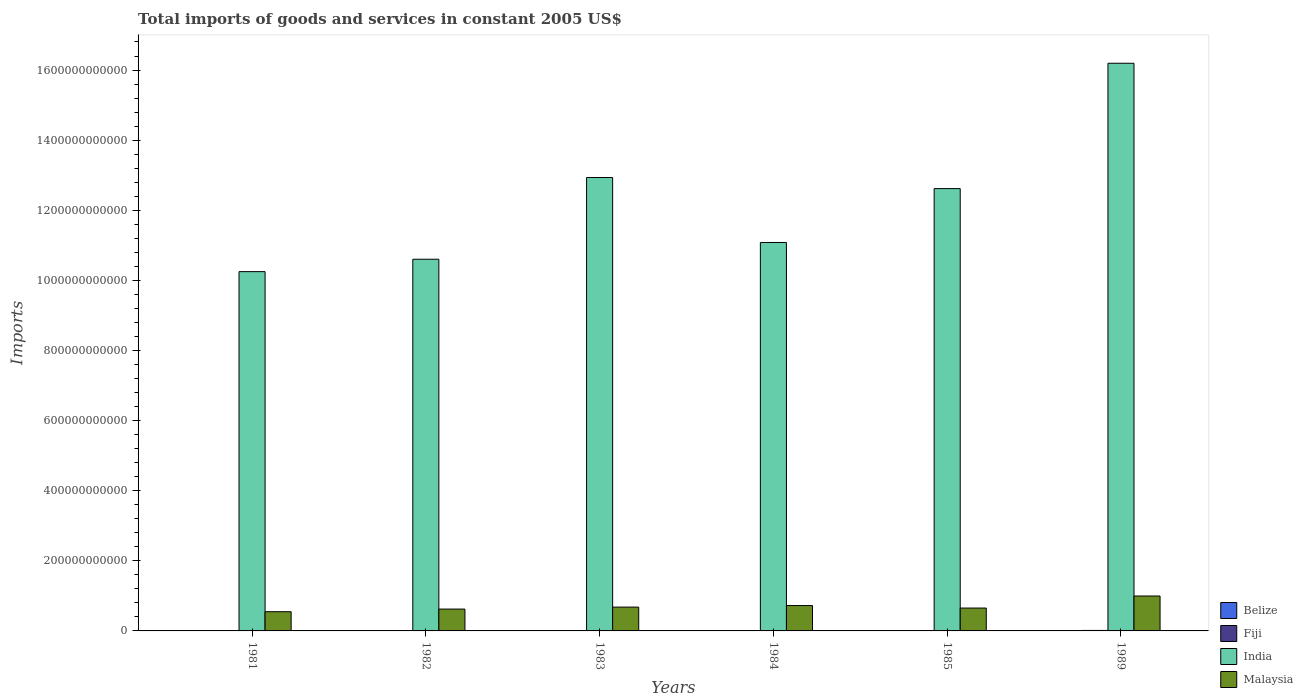How many different coloured bars are there?
Your answer should be very brief. 4. Are the number of bars per tick equal to the number of legend labels?
Make the answer very short. Yes. How many bars are there on the 4th tick from the left?
Offer a terse response. 4. What is the total imports of goods and services in Fiji in 1983?
Offer a terse response. 9.05e+08. Across all years, what is the maximum total imports of goods and services in Malaysia?
Offer a terse response. 9.96e+1. Across all years, what is the minimum total imports of goods and services in Fiji?
Offer a terse response. 8.65e+08. What is the total total imports of goods and services in Belize in the graph?
Your answer should be compact. 2.58e+09. What is the difference between the total imports of goods and services in Malaysia in 1983 and that in 1984?
Give a very brief answer. -4.42e+09. What is the difference between the total imports of goods and services in Belize in 1983 and the total imports of goods and services in Fiji in 1984?
Your answer should be very brief. -5.09e+08. What is the average total imports of goods and services in Fiji per year?
Provide a short and direct response. 1.01e+09. In the year 1981, what is the difference between the total imports of goods and services in Malaysia and total imports of goods and services in India?
Ensure brevity in your answer.  -9.70e+11. In how many years, is the total imports of goods and services in India greater than 1080000000000 US$?
Your answer should be very brief. 4. What is the ratio of the total imports of goods and services in Belize in 1982 to that in 1984?
Give a very brief answer. 1.01. Is the difference between the total imports of goods and services in Malaysia in 1981 and 1989 greater than the difference between the total imports of goods and services in India in 1981 and 1989?
Ensure brevity in your answer.  Yes. What is the difference between the highest and the second highest total imports of goods and services in Fiji?
Provide a short and direct response. 3.37e+08. What is the difference between the highest and the lowest total imports of goods and services in Malaysia?
Your answer should be very brief. 4.48e+1. In how many years, is the total imports of goods and services in India greater than the average total imports of goods and services in India taken over all years?
Give a very brief answer. 3. What does the 1st bar from the right in 1985 represents?
Make the answer very short. Malaysia. Is it the case that in every year, the sum of the total imports of goods and services in India and total imports of goods and services in Belize is greater than the total imports of goods and services in Malaysia?
Provide a succinct answer. Yes. What is the difference between two consecutive major ticks on the Y-axis?
Your answer should be very brief. 2.00e+11. What is the title of the graph?
Your answer should be very brief. Total imports of goods and services in constant 2005 US$. What is the label or title of the X-axis?
Provide a succinct answer. Years. What is the label or title of the Y-axis?
Keep it short and to the point. Imports. What is the Imports in Belize in 1981?
Provide a short and direct response. 4.41e+08. What is the Imports in Fiji in 1981?
Offer a terse response. 1.06e+09. What is the Imports of India in 1981?
Provide a short and direct response. 1.02e+12. What is the Imports of Malaysia in 1981?
Offer a very short reply. 5.48e+1. What is the Imports of Belize in 1982?
Your answer should be compact. 4.12e+08. What is the Imports in Fiji in 1982?
Provide a succinct answer. 9.40e+08. What is the Imports of India in 1982?
Your answer should be compact. 1.06e+12. What is the Imports in Malaysia in 1982?
Provide a short and direct response. 6.23e+1. What is the Imports in Belize in 1983?
Your answer should be very brief. 3.72e+08. What is the Imports in Fiji in 1983?
Make the answer very short. 9.05e+08. What is the Imports of India in 1983?
Your response must be concise. 1.29e+12. What is the Imports in Malaysia in 1983?
Offer a terse response. 6.79e+1. What is the Imports of Belize in 1984?
Ensure brevity in your answer.  4.09e+08. What is the Imports of Fiji in 1984?
Make the answer very short. 8.81e+08. What is the Imports of India in 1984?
Provide a short and direct response. 1.11e+12. What is the Imports in Malaysia in 1984?
Offer a terse response. 7.24e+1. What is the Imports of Belize in 1985?
Offer a terse response. 3.61e+08. What is the Imports in Fiji in 1985?
Provide a succinct answer. 8.65e+08. What is the Imports of India in 1985?
Your response must be concise. 1.26e+12. What is the Imports of Malaysia in 1985?
Offer a very short reply. 6.52e+1. What is the Imports in Belize in 1989?
Offer a very short reply. 5.85e+08. What is the Imports in Fiji in 1989?
Your response must be concise. 1.39e+09. What is the Imports in India in 1989?
Offer a terse response. 1.62e+12. What is the Imports in Malaysia in 1989?
Ensure brevity in your answer.  9.96e+1. Across all years, what is the maximum Imports of Belize?
Your response must be concise. 5.85e+08. Across all years, what is the maximum Imports of Fiji?
Your answer should be very brief. 1.39e+09. Across all years, what is the maximum Imports of India?
Keep it short and to the point. 1.62e+12. Across all years, what is the maximum Imports of Malaysia?
Your answer should be compact. 9.96e+1. Across all years, what is the minimum Imports of Belize?
Your answer should be very brief. 3.61e+08. Across all years, what is the minimum Imports of Fiji?
Offer a terse response. 8.65e+08. Across all years, what is the minimum Imports of India?
Provide a short and direct response. 1.02e+12. Across all years, what is the minimum Imports in Malaysia?
Your response must be concise. 5.48e+1. What is the total Imports of Belize in the graph?
Keep it short and to the point. 2.58e+09. What is the total Imports in Fiji in the graph?
Your answer should be very brief. 6.04e+09. What is the total Imports of India in the graph?
Offer a terse response. 7.37e+12. What is the total Imports of Malaysia in the graph?
Ensure brevity in your answer.  4.22e+11. What is the difference between the Imports in Belize in 1981 and that in 1982?
Your answer should be very brief. 2.92e+07. What is the difference between the Imports of Fiji in 1981 and that in 1982?
Your answer should be compact. 1.15e+08. What is the difference between the Imports in India in 1981 and that in 1982?
Your response must be concise. -3.54e+1. What is the difference between the Imports of Malaysia in 1981 and that in 1982?
Your answer should be very brief. -7.54e+09. What is the difference between the Imports of Belize in 1981 and that in 1983?
Give a very brief answer. 6.97e+07. What is the difference between the Imports of Fiji in 1981 and that in 1983?
Your answer should be very brief. 1.50e+08. What is the difference between the Imports of India in 1981 and that in 1983?
Keep it short and to the point. -2.69e+11. What is the difference between the Imports in Malaysia in 1981 and that in 1983?
Keep it short and to the point. -1.31e+1. What is the difference between the Imports in Belize in 1981 and that in 1984?
Provide a succinct answer. 3.24e+07. What is the difference between the Imports in Fiji in 1981 and that in 1984?
Keep it short and to the point. 1.75e+08. What is the difference between the Imports in India in 1981 and that in 1984?
Your response must be concise. -8.32e+1. What is the difference between the Imports of Malaysia in 1981 and that in 1984?
Keep it short and to the point. -1.76e+1. What is the difference between the Imports of Belize in 1981 and that in 1985?
Your answer should be compact. 8.02e+07. What is the difference between the Imports in Fiji in 1981 and that in 1985?
Offer a terse response. 1.90e+08. What is the difference between the Imports in India in 1981 and that in 1985?
Offer a very short reply. -2.37e+11. What is the difference between the Imports in Malaysia in 1981 and that in 1985?
Your response must be concise. -1.05e+1. What is the difference between the Imports of Belize in 1981 and that in 1989?
Keep it short and to the point. -1.44e+08. What is the difference between the Imports of Fiji in 1981 and that in 1989?
Offer a terse response. -3.37e+08. What is the difference between the Imports in India in 1981 and that in 1989?
Provide a short and direct response. -5.94e+11. What is the difference between the Imports in Malaysia in 1981 and that in 1989?
Give a very brief answer. -4.48e+1. What is the difference between the Imports of Belize in 1982 and that in 1983?
Your answer should be compact. 4.05e+07. What is the difference between the Imports in Fiji in 1982 and that in 1983?
Offer a terse response. 3.47e+07. What is the difference between the Imports in India in 1982 and that in 1983?
Provide a succinct answer. -2.33e+11. What is the difference between the Imports in Malaysia in 1982 and that in 1983?
Your answer should be compact. -5.61e+09. What is the difference between the Imports in Belize in 1982 and that in 1984?
Offer a terse response. 3.23e+06. What is the difference between the Imports in Fiji in 1982 and that in 1984?
Provide a succinct answer. 5.93e+07. What is the difference between the Imports in India in 1982 and that in 1984?
Offer a terse response. -4.78e+1. What is the difference between the Imports of Malaysia in 1982 and that in 1984?
Provide a short and direct response. -1.00e+1. What is the difference between the Imports of Belize in 1982 and that in 1985?
Offer a terse response. 5.10e+07. What is the difference between the Imports of Fiji in 1982 and that in 1985?
Your response must be concise. 7.51e+07. What is the difference between the Imports in India in 1982 and that in 1985?
Your answer should be very brief. -2.01e+11. What is the difference between the Imports of Malaysia in 1982 and that in 1985?
Your answer should be compact. -2.91e+09. What is the difference between the Imports in Belize in 1982 and that in 1989?
Your answer should be compact. -1.73e+08. What is the difference between the Imports in Fiji in 1982 and that in 1989?
Offer a terse response. -4.52e+08. What is the difference between the Imports of India in 1982 and that in 1989?
Keep it short and to the point. -5.59e+11. What is the difference between the Imports of Malaysia in 1982 and that in 1989?
Offer a very short reply. -3.73e+1. What is the difference between the Imports in Belize in 1983 and that in 1984?
Provide a short and direct response. -3.73e+07. What is the difference between the Imports of Fiji in 1983 and that in 1984?
Give a very brief answer. 2.47e+07. What is the difference between the Imports in India in 1983 and that in 1984?
Your response must be concise. 1.85e+11. What is the difference between the Imports in Malaysia in 1983 and that in 1984?
Your answer should be very brief. -4.42e+09. What is the difference between the Imports in Belize in 1983 and that in 1985?
Give a very brief answer. 1.05e+07. What is the difference between the Imports in Fiji in 1983 and that in 1985?
Offer a very short reply. 4.04e+07. What is the difference between the Imports in India in 1983 and that in 1985?
Give a very brief answer. 3.16e+1. What is the difference between the Imports in Malaysia in 1983 and that in 1985?
Make the answer very short. 2.70e+09. What is the difference between the Imports of Belize in 1983 and that in 1989?
Your answer should be very brief. -2.14e+08. What is the difference between the Imports in Fiji in 1983 and that in 1989?
Ensure brevity in your answer.  -4.87e+08. What is the difference between the Imports in India in 1983 and that in 1989?
Ensure brevity in your answer.  -3.26e+11. What is the difference between the Imports of Malaysia in 1983 and that in 1989?
Offer a very short reply. -3.17e+1. What is the difference between the Imports of Belize in 1984 and that in 1985?
Your response must be concise. 4.78e+07. What is the difference between the Imports of Fiji in 1984 and that in 1985?
Your answer should be very brief. 1.58e+07. What is the difference between the Imports in India in 1984 and that in 1985?
Give a very brief answer. -1.54e+11. What is the difference between the Imports in Malaysia in 1984 and that in 1985?
Ensure brevity in your answer.  7.12e+09. What is the difference between the Imports in Belize in 1984 and that in 1989?
Your answer should be compact. -1.76e+08. What is the difference between the Imports in Fiji in 1984 and that in 1989?
Your answer should be compact. -5.11e+08. What is the difference between the Imports in India in 1984 and that in 1989?
Make the answer very short. -5.11e+11. What is the difference between the Imports of Malaysia in 1984 and that in 1989?
Keep it short and to the point. -2.73e+1. What is the difference between the Imports of Belize in 1985 and that in 1989?
Ensure brevity in your answer.  -2.24e+08. What is the difference between the Imports of Fiji in 1985 and that in 1989?
Your answer should be compact. -5.27e+08. What is the difference between the Imports in India in 1985 and that in 1989?
Ensure brevity in your answer.  -3.58e+11. What is the difference between the Imports in Malaysia in 1985 and that in 1989?
Give a very brief answer. -3.44e+1. What is the difference between the Imports of Belize in 1981 and the Imports of Fiji in 1982?
Make the answer very short. -4.98e+08. What is the difference between the Imports of Belize in 1981 and the Imports of India in 1982?
Provide a succinct answer. -1.06e+12. What is the difference between the Imports of Belize in 1981 and the Imports of Malaysia in 1982?
Keep it short and to the point. -6.19e+1. What is the difference between the Imports in Fiji in 1981 and the Imports in India in 1982?
Ensure brevity in your answer.  -1.06e+12. What is the difference between the Imports of Fiji in 1981 and the Imports of Malaysia in 1982?
Offer a terse response. -6.13e+1. What is the difference between the Imports in India in 1981 and the Imports in Malaysia in 1982?
Your answer should be very brief. 9.63e+11. What is the difference between the Imports in Belize in 1981 and the Imports in Fiji in 1983?
Provide a short and direct response. -4.64e+08. What is the difference between the Imports of Belize in 1981 and the Imports of India in 1983?
Your answer should be very brief. -1.29e+12. What is the difference between the Imports in Belize in 1981 and the Imports in Malaysia in 1983?
Ensure brevity in your answer.  -6.75e+1. What is the difference between the Imports of Fiji in 1981 and the Imports of India in 1983?
Your response must be concise. -1.29e+12. What is the difference between the Imports in Fiji in 1981 and the Imports in Malaysia in 1983?
Your answer should be very brief. -6.69e+1. What is the difference between the Imports in India in 1981 and the Imports in Malaysia in 1983?
Offer a very short reply. 9.57e+11. What is the difference between the Imports of Belize in 1981 and the Imports of Fiji in 1984?
Provide a short and direct response. -4.39e+08. What is the difference between the Imports of Belize in 1981 and the Imports of India in 1984?
Give a very brief answer. -1.11e+12. What is the difference between the Imports of Belize in 1981 and the Imports of Malaysia in 1984?
Make the answer very short. -7.19e+1. What is the difference between the Imports of Fiji in 1981 and the Imports of India in 1984?
Make the answer very short. -1.11e+12. What is the difference between the Imports of Fiji in 1981 and the Imports of Malaysia in 1984?
Provide a succinct answer. -7.13e+1. What is the difference between the Imports in India in 1981 and the Imports in Malaysia in 1984?
Your answer should be very brief. 9.53e+11. What is the difference between the Imports of Belize in 1981 and the Imports of Fiji in 1985?
Your answer should be compact. -4.23e+08. What is the difference between the Imports in Belize in 1981 and the Imports in India in 1985?
Your response must be concise. -1.26e+12. What is the difference between the Imports of Belize in 1981 and the Imports of Malaysia in 1985?
Provide a short and direct response. -6.48e+1. What is the difference between the Imports in Fiji in 1981 and the Imports in India in 1985?
Keep it short and to the point. -1.26e+12. What is the difference between the Imports of Fiji in 1981 and the Imports of Malaysia in 1985?
Offer a terse response. -6.42e+1. What is the difference between the Imports of India in 1981 and the Imports of Malaysia in 1985?
Provide a succinct answer. 9.60e+11. What is the difference between the Imports of Belize in 1981 and the Imports of Fiji in 1989?
Provide a succinct answer. -9.50e+08. What is the difference between the Imports in Belize in 1981 and the Imports in India in 1989?
Make the answer very short. -1.62e+12. What is the difference between the Imports in Belize in 1981 and the Imports in Malaysia in 1989?
Your answer should be compact. -9.92e+1. What is the difference between the Imports of Fiji in 1981 and the Imports of India in 1989?
Your answer should be compact. -1.62e+12. What is the difference between the Imports of Fiji in 1981 and the Imports of Malaysia in 1989?
Provide a short and direct response. -9.86e+1. What is the difference between the Imports in India in 1981 and the Imports in Malaysia in 1989?
Keep it short and to the point. 9.25e+11. What is the difference between the Imports of Belize in 1982 and the Imports of Fiji in 1983?
Your answer should be compact. -4.93e+08. What is the difference between the Imports in Belize in 1982 and the Imports in India in 1983?
Ensure brevity in your answer.  -1.29e+12. What is the difference between the Imports in Belize in 1982 and the Imports in Malaysia in 1983?
Give a very brief answer. -6.75e+1. What is the difference between the Imports of Fiji in 1982 and the Imports of India in 1983?
Provide a succinct answer. -1.29e+12. What is the difference between the Imports of Fiji in 1982 and the Imports of Malaysia in 1983?
Offer a very short reply. -6.70e+1. What is the difference between the Imports of India in 1982 and the Imports of Malaysia in 1983?
Provide a succinct answer. 9.92e+11. What is the difference between the Imports in Belize in 1982 and the Imports in Fiji in 1984?
Offer a very short reply. -4.68e+08. What is the difference between the Imports in Belize in 1982 and the Imports in India in 1984?
Offer a very short reply. -1.11e+12. What is the difference between the Imports in Belize in 1982 and the Imports in Malaysia in 1984?
Give a very brief answer. -7.20e+1. What is the difference between the Imports in Fiji in 1982 and the Imports in India in 1984?
Your response must be concise. -1.11e+12. What is the difference between the Imports in Fiji in 1982 and the Imports in Malaysia in 1984?
Give a very brief answer. -7.14e+1. What is the difference between the Imports in India in 1982 and the Imports in Malaysia in 1984?
Provide a short and direct response. 9.88e+11. What is the difference between the Imports of Belize in 1982 and the Imports of Fiji in 1985?
Your answer should be very brief. -4.53e+08. What is the difference between the Imports of Belize in 1982 and the Imports of India in 1985?
Keep it short and to the point. -1.26e+12. What is the difference between the Imports in Belize in 1982 and the Imports in Malaysia in 1985?
Offer a very short reply. -6.48e+1. What is the difference between the Imports in Fiji in 1982 and the Imports in India in 1985?
Your answer should be very brief. -1.26e+12. What is the difference between the Imports of Fiji in 1982 and the Imports of Malaysia in 1985?
Your answer should be compact. -6.43e+1. What is the difference between the Imports of India in 1982 and the Imports of Malaysia in 1985?
Offer a terse response. 9.95e+11. What is the difference between the Imports in Belize in 1982 and the Imports in Fiji in 1989?
Offer a very short reply. -9.79e+08. What is the difference between the Imports of Belize in 1982 and the Imports of India in 1989?
Your answer should be very brief. -1.62e+12. What is the difference between the Imports in Belize in 1982 and the Imports in Malaysia in 1989?
Give a very brief answer. -9.92e+1. What is the difference between the Imports in Fiji in 1982 and the Imports in India in 1989?
Offer a terse response. -1.62e+12. What is the difference between the Imports of Fiji in 1982 and the Imports of Malaysia in 1989?
Give a very brief answer. -9.87e+1. What is the difference between the Imports in India in 1982 and the Imports in Malaysia in 1989?
Give a very brief answer. 9.61e+11. What is the difference between the Imports of Belize in 1983 and the Imports of Fiji in 1984?
Provide a succinct answer. -5.09e+08. What is the difference between the Imports of Belize in 1983 and the Imports of India in 1984?
Make the answer very short. -1.11e+12. What is the difference between the Imports of Belize in 1983 and the Imports of Malaysia in 1984?
Your response must be concise. -7.20e+1. What is the difference between the Imports in Fiji in 1983 and the Imports in India in 1984?
Your response must be concise. -1.11e+12. What is the difference between the Imports in Fiji in 1983 and the Imports in Malaysia in 1984?
Give a very brief answer. -7.15e+1. What is the difference between the Imports in India in 1983 and the Imports in Malaysia in 1984?
Ensure brevity in your answer.  1.22e+12. What is the difference between the Imports in Belize in 1983 and the Imports in Fiji in 1985?
Offer a very short reply. -4.93e+08. What is the difference between the Imports of Belize in 1983 and the Imports of India in 1985?
Keep it short and to the point. -1.26e+12. What is the difference between the Imports in Belize in 1983 and the Imports in Malaysia in 1985?
Give a very brief answer. -6.49e+1. What is the difference between the Imports of Fiji in 1983 and the Imports of India in 1985?
Your response must be concise. -1.26e+12. What is the difference between the Imports in Fiji in 1983 and the Imports in Malaysia in 1985?
Provide a succinct answer. -6.43e+1. What is the difference between the Imports of India in 1983 and the Imports of Malaysia in 1985?
Your answer should be very brief. 1.23e+12. What is the difference between the Imports in Belize in 1983 and the Imports in Fiji in 1989?
Ensure brevity in your answer.  -1.02e+09. What is the difference between the Imports of Belize in 1983 and the Imports of India in 1989?
Your answer should be very brief. -1.62e+12. What is the difference between the Imports in Belize in 1983 and the Imports in Malaysia in 1989?
Give a very brief answer. -9.92e+1. What is the difference between the Imports of Fiji in 1983 and the Imports of India in 1989?
Ensure brevity in your answer.  -1.62e+12. What is the difference between the Imports in Fiji in 1983 and the Imports in Malaysia in 1989?
Offer a terse response. -9.87e+1. What is the difference between the Imports of India in 1983 and the Imports of Malaysia in 1989?
Provide a succinct answer. 1.19e+12. What is the difference between the Imports in Belize in 1984 and the Imports in Fiji in 1985?
Provide a short and direct response. -4.56e+08. What is the difference between the Imports in Belize in 1984 and the Imports in India in 1985?
Your response must be concise. -1.26e+12. What is the difference between the Imports in Belize in 1984 and the Imports in Malaysia in 1985?
Make the answer very short. -6.48e+1. What is the difference between the Imports of Fiji in 1984 and the Imports of India in 1985?
Keep it short and to the point. -1.26e+12. What is the difference between the Imports of Fiji in 1984 and the Imports of Malaysia in 1985?
Give a very brief answer. -6.44e+1. What is the difference between the Imports in India in 1984 and the Imports in Malaysia in 1985?
Provide a succinct answer. 1.04e+12. What is the difference between the Imports in Belize in 1984 and the Imports in Fiji in 1989?
Your answer should be very brief. -9.83e+08. What is the difference between the Imports of Belize in 1984 and the Imports of India in 1989?
Your answer should be very brief. -1.62e+12. What is the difference between the Imports in Belize in 1984 and the Imports in Malaysia in 1989?
Ensure brevity in your answer.  -9.92e+1. What is the difference between the Imports of Fiji in 1984 and the Imports of India in 1989?
Your answer should be compact. -1.62e+12. What is the difference between the Imports in Fiji in 1984 and the Imports in Malaysia in 1989?
Provide a short and direct response. -9.87e+1. What is the difference between the Imports of India in 1984 and the Imports of Malaysia in 1989?
Your answer should be compact. 1.01e+12. What is the difference between the Imports in Belize in 1985 and the Imports in Fiji in 1989?
Offer a very short reply. -1.03e+09. What is the difference between the Imports of Belize in 1985 and the Imports of India in 1989?
Your response must be concise. -1.62e+12. What is the difference between the Imports in Belize in 1985 and the Imports in Malaysia in 1989?
Your answer should be very brief. -9.93e+1. What is the difference between the Imports of Fiji in 1985 and the Imports of India in 1989?
Provide a short and direct response. -1.62e+12. What is the difference between the Imports of Fiji in 1985 and the Imports of Malaysia in 1989?
Provide a short and direct response. -9.87e+1. What is the difference between the Imports of India in 1985 and the Imports of Malaysia in 1989?
Offer a very short reply. 1.16e+12. What is the average Imports in Belize per year?
Your answer should be compact. 4.30e+08. What is the average Imports in Fiji per year?
Offer a very short reply. 1.01e+09. What is the average Imports of India per year?
Offer a very short reply. 1.23e+12. What is the average Imports in Malaysia per year?
Your response must be concise. 7.04e+1. In the year 1981, what is the difference between the Imports in Belize and Imports in Fiji?
Offer a terse response. -6.14e+08. In the year 1981, what is the difference between the Imports in Belize and Imports in India?
Make the answer very short. -1.02e+12. In the year 1981, what is the difference between the Imports of Belize and Imports of Malaysia?
Offer a very short reply. -5.44e+1. In the year 1981, what is the difference between the Imports of Fiji and Imports of India?
Offer a very short reply. -1.02e+12. In the year 1981, what is the difference between the Imports of Fiji and Imports of Malaysia?
Give a very brief answer. -5.37e+1. In the year 1981, what is the difference between the Imports in India and Imports in Malaysia?
Offer a terse response. 9.70e+11. In the year 1982, what is the difference between the Imports of Belize and Imports of Fiji?
Your answer should be very brief. -5.28e+08. In the year 1982, what is the difference between the Imports in Belize and Imports in India?
Make the answer very short. -1.06e+12. In the year 1982, what is the difference between the Imports in Belize and Imports in Malaysia?
Give a very brief answer. -6.19e+1. In the year 1982, what is the difference between the Imports in Fiji and Imports in India?
Keep it short and to the point. -1.06e+12. In the year 1982, what is the difference between the Imports of Fiji and Imports of Malaysia?
Provide a short and direct response. -6.14e+1. In the year 1982, what is the difference between the Imports in India and Imports in Malaysia?
Offer a very short reply. 9.98e+11. In the year 1983, what is the difference between the Imports of Belize and Imports of Fiji?
Make the answer very short. -5.34e+08. In the year 1983, what is the difference between the Imports of Belize and Imports of India?
Give a very brief answer. -1.29e+12. In the year 1983, what is the difference between the Imports in Belize and Imports in Malaysia?
Your response must be concise. -6.76e+1. In the year 1983, what is the difference between the Imports of Fiji and Imports of India?
Offer a terse response. -1.29e+12. In the year 1983, what is the difference between the Imports of Fiji and Imports of Malaysia?
Ensure brevity in your answer.  -6.70e+1. In the year 1983, what is the difference between the Imports of India and Imports of Malaysia?
Make the answer very short. 1.23e+12. In the year 1984, what is the difference between the Imports of Belize and Imports of Fiji?
Ensure brevity in your answer.  -4.72e+08. In the year 1984, what is the difference between the Imports of Belize and Imports of India?
Keep it short and to the point. -1.11e+12. In the year 1984, what is the difference between the Imports of Belize and Imports of Malaysia?
Offer a very short reply. -7.20e+1. In the year 1984, what is the difference between the Imports in Fiji and Imports in India?
Provide a short and direct response. -1.11e+12. In the year 1984, what is the difference between the Imports in Fiji and Imports in Malaysia?
Offer a terse response. -7.15e+1. In the year 1984, what is the difference between the Imports in India and Imports in Malaysia?
Provide a short and direct response. 1.04e+12. In the year 1985, what is the difference between the Imports of Belize and Imports of Fiji?
Keep it short and to the point. -5.04e+08. In the year 1985, what is the difference between the Imports of Belize and Imports of India?
Provide a succinct answer. -1.26e+12. In the year 1985, what is the difference between the Imports in Belize and Imports in Malaysia?
Your answer should be very brief. -6.49e+1. In the year 1985, what is the difference between the Imports of Fiji and Imports of India?
Keep it short and to the point. -1.26e+12. In the year 1985, what is the difference between the Imports of Fiji and Imports of Malaysia?
Your response must be concise. -6.44e+1. In the year 1985, what is the difference between the Imports of India and Imports of Malaysia?
Offer a very short reply. 1.20e+12. In the year 1989, what is the difference between the Imports of Belize and Imports of Fiji?
Provide a succinct answer. -8.06e+08. In the year 1989, what is the difference between the Imports of Belize and Imports of India?
Your response must be concise. -1.62e+12. In the year 1989, what is the difference between the Imports of Belize and Imports of Malaysia?
Your answer should be compact. -9.90e+1. In the year 1989, what is the difference between the Imports in Fiji and Imports in India?
Your answer should be compact. -1.62e+12. In the year 1989, what is the difference between the Imports of Fiji and Imports of Malaysia?
Provide a short and direct response. -9.82e+1. In the year 1989, what is the difference between the Imports of India and Imports of Malaysia?
Offer a terse response. 1.52e+12. What is the ratio of the Imports of Belize in 1981 to that in 1982?
Ensure brevity in your answer.  1.07. What is the ratio of the Imports of Fiji in 1981 to that in 1982?
Ensure brevity in your answer.  1.12. What is the ratio of the Imports of India in 1981 to that in 1982?
Keep it short and to the point. 0.97. What is the ratio of the Imports in Malaysia in 1981 to that in 1982?
Provide a short and direct response. 0.88. What is the ratio of the Imports in Belize in 1981 to that in 1983?
Ensure brevity in your answer.  1.19. What is the ratio of the Imports of Fiji in 1981 to that in 1983?
Keep it short and to the point. 1.17. What is the ratio of the Imports in India in 1981 to that in 1983?
Offer a terse response. 0.79. What is the ratio of the Imports of Malaysia in 1981 to that in 1983?
Your answer should be very brief. 0.81. What is the ratio of the Imports in Belize in 1981 to that in 1984?
Provide a short and direct response. 1.08. What is the ratio of the Imports of Fiji in 1981 to that in 1984?
Offer a very short reply. 1.2. What is the ratio of the Imports in India in 1981 to that in 1984?
Make the answer very short. 0.93. What is the ratio of the Imports in Malaysia in 1981 to that in 1984?
Your answer should be compact. 0.76. What is the ratio of the Imports of Belize in 1981 to that in 1985?
Provide a short and direct response. 1.22. What is the ratio of the Imports in Fiji in 1981 to that in 1985?
Your answer should be compact. 1.22. What is the ratio of the Imports in India in 1981 to that in 1985?
Your answer should be compact. 0.81. What is the ratio of the Imports in Malaysia in 1981 to that in 1985?
Your answer should be compact. 0.84. What is the ratio of the Imports in Belize in 1981 to that in 1989?
Your answer should be very brief. 0.75. What is the ratio of the Imports in Fiji in 1981 to that in 1989?
Offer a very short reply. 0.76. What is the ratio of the Imports in India in 1981 to that in 1989?
Keep it short and to the point. 0.63. What is the ratio of the Imports of Malaysia in 1981 to that in 1989?
Provide a succinct answer. 0.55. What is the ratio of the Imports in Belize in 1982 to that in 1983?
Your answer should be compact. 1.11. What is the ratio of the Imports of Fiji in 1982 to that in 1983?
Offer a terse response. 1.04. What is the ratio of the Imports in India in 1982 to that in 1983?
Your answer should be very brief. 0.82. What is the ratio of the Imports in Malaysia in 1982 to that in 1983?
Provide a succinct answer. 0.92. What is the ratio of the Imports of Belize in 1982 to that in 1984?
Ensure brevity in your answer.  1.01. What is the ratio of the Imports in Fiji in 1982 to that in 1984?
Your response must be concise. 1.07. What is the ratio of the Imports in India in 1982 to that in 1984?
Offer a very short reply. 0.96. What is the ratio of the Imports of Malaysia in 1982 to that in 1984?
Provide a succinct answer. 0.86. What is the ratio of the Imports in Belize in 1982 to that in 1985?
Your answer should be very brief. 1.14. What is the ratio of the Imports of Fiji in 1982 to that in 1985?
Your answer should be compact. 1.09. What is the ratio of the Imports of India in 1982 to that in 1985?
Make the answer very short. 0.84. What is the ratio of the Imports in Malaysia in 1982 to that in 1985?
Keep it short and to the point. 0.96. What is the ratio of the Imports in Belize in 1982 to that in 1989?
Keep it short and to the point. 0.7. What is the ratio of the Imports of Fiji in 1982 to that in 1989?
Offer a very short reply. 0.68. What is the ratio of the Imports of India in 1982 to that in 1989?
Your answer should be very brief. 0.65. What is the ratio of the Imports in Malaysia in 1982 to that in 1989?
Give a very brief answer. 0.63. What is the ratio of the Imports of Belize in 1983 to that in 1984?
Provide a short and direct response. 0.91. What is the ratio of the Imports of Fiji in 1983 to that in 1984?
Provide a short and direct response. 1.03. What is the ratio of the Imports in India in 1983 to that in 1984?
Ensure brevity in your answer.  1.17. What is the ratio of the Imports of Malaysia in 1983 to that in 1984?
Provide a short and direct response. 0.94. What is the ratio of the Imports of Belize in 1983 to that in 1985?
Offer a very short reply. 1.03. What is the ratio of the Imports of Fiji in 1983 to that in 1985?
Ensure brevity in your answer.  1.05. What is the ratio of the Imports of India in 1983 to that in 1985?
Your answer should be compact. 1.03. What is the ratio of the Imports of Malaysia in 1983 to that in 1985?
Give a very brief answer. 1.04. What is the ratio of the Imports in Belize in 1983 to that in 1989?
Provide a short and direct response. 0.64. What is the ratio of the Imports of Fiji in 1983 to that in 1989?
Provide a short and direct response. 0.65. What is the ratio of the Imports in India in 1983 to that in 1989?
Your answer should be compact. 0.8. What is the ratio of the Imports in Malaysia in 1983 to that in 1989?
Provide a short and direct response. 0.68. What is the ratio of the Imports of Belize in 1984 to that in 1985?
Your answer should be very brief. 1.13. What is the ratio of the Imports of Fiji in 1984 to that in 1985?
Make the answer very short. 1.02. What is the ratio of the Imports of India in 1984 to that in 1985?
Keep it short and to the point. 0.88. What is the ratio of the Imports of Malaysia in 1984 to that in 1985?
Make the answer very short. 1.11. What is the ratio of the Imports in Belize in 1984 to that in 1989?
Provide a succinct answer. 0.7. What is the ratio of the Imports of Fiji in 1984 to that in 1989?
Offer a very short reply. 0.63. What is the ratio of the Imports of India in 1984 to that in 1989?
Provide a short and direct response. 0.68. What is the ratio of the Imports in Malaysia in 1984 to that in 1989?
Your answer should be compact. 0.73. What is the ratio of the Imports in Belize in 1985 to that in 1989?
Your response must be concise. 0.62. What is the ratio of the Imports in Fiji in 1985 to that in 1989?
Offer a very short reply. 0.62. What is the ratio of the Imports of India in 1985 to that in 1989?
Your answer should be compact. 0.78. What is the ratio of the Imports in Malaysia in 1985 to that in 1989?
Keep it short and to the point. 0.66. What is the difference between the highest and the second highest Imports of Belize?
Ensure brevity in your answer.  1.44e+08. What is the difference between the highest and the second highest Imports of Fiji?
Provide a short and direct response. 3.37e+08. What is the difference between the highest and the second highest Imports of India?
Your answer should be compact. 3.26e+11. What is the difference between the highest and the second highest Imports of Malaysia?
Your response must be concise. 2.73e+1. What is the difference between the highest and the lowest Imports of Belize?
Provide a short and direct response. 2.24e+08. What is the difference between the highest and the lowest Imports of Fiji?
Offer a terse response. 5.27e+08. What is the difference between the highest and the lowest Imports in India?
Give a very brief answer. 5.94e+11. What is the difference between the highest and the lowest Imports of Malaysia?
Your answer should be very brief. 4.48e+1. 